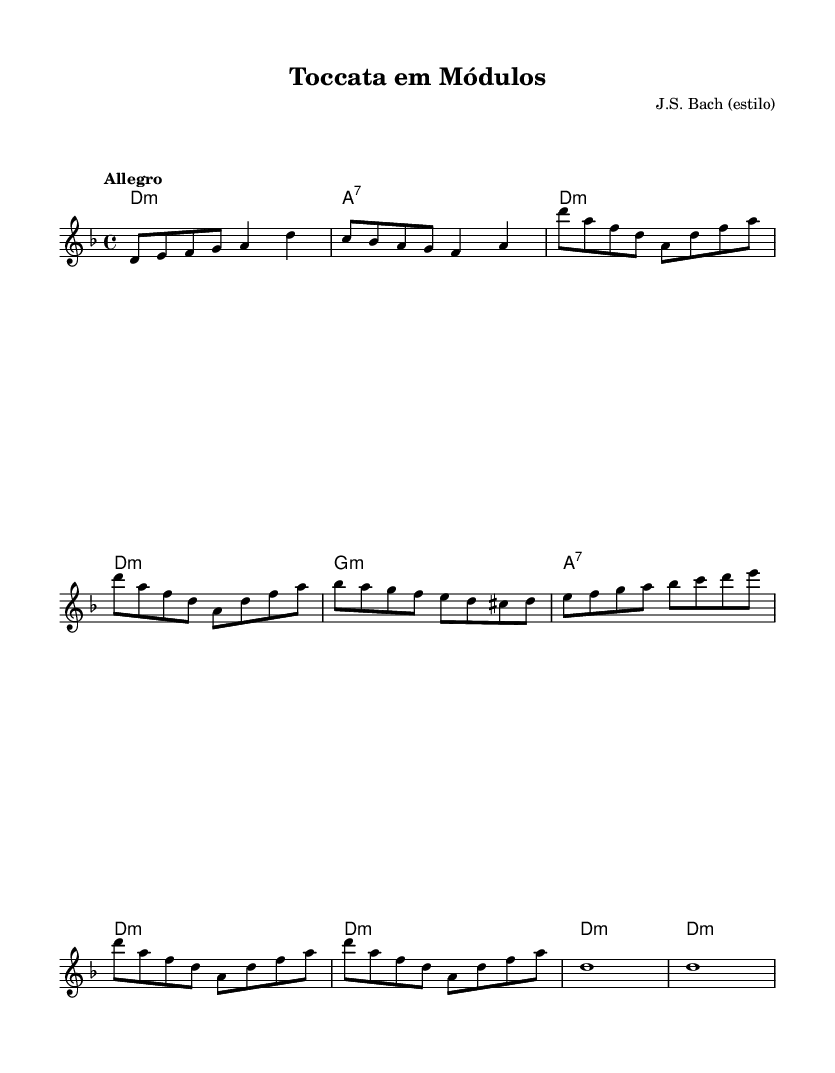What is the key signature of this music? The key signature indicates two flats (B♭ and E♭), which corresponds to D minor where the melody frequently uses these notes.
Answer: D minor What is the time signature of this piece? The time signature shown at the beginning of the score is 4/4, indicating four beats per measure.
Answer: 4/4 What is the tempo marking for this composition? The tempo marking specifies "Allegro," which indicates a fast and lively pace for the piece.
Answer: Allegro How many different modules are introduced in the music? There are three distinct parts: Introduction, Tema Principal, and Desenvolvimento, showing the modular aspect.
Answer: Three What type of harmonic structure is primarily used in this piece? The harmonic structure alternates primarily between minor and seventh chords, providing a Baroque richness to the sound.
Answer: Minor and seventh chords How does the repetition of the Tema Principal emphasize its role in the work? The repetition reinforces the theme's significance, typical in Baroque music, serving as a return to a recognizable musical idea.
Answer: It emphasizes the theme's importance 